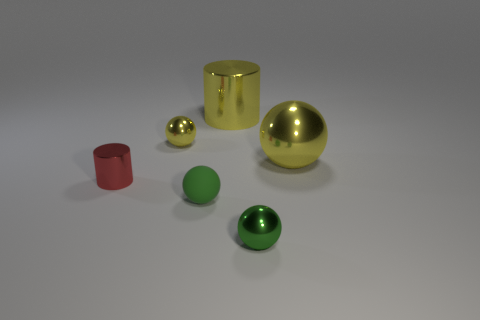There is another sphere that is the same color as the matte ball; what is its material?
Provide a short and direct response. Metal. How many yellow things are there?
Your response must be concise. 3. What number of tiny objects are balls or green metal things?
Make the answer very short. 3. The green shiny object that is the same size as the green rubber sphere is what shape?
Give a very brief answer. Sphere. There is a green sphere that is on the left side of the object behind the small yellow object; what is it made of?
Provide a succinct answer. Rubber. Do the rubber thing and the yellow metallic cylinder have the same size?
Your answer should be compact. No. What number of objects are things that are in front of the matte sphere or big shiny balls?
Keep it short and to the point. 2. There is a tiny green thing that is behind the small green metallic object right of the small rubber object; what shape is it?
Offer a terse response. Sphere. There is a red object; does it have the same size as the metallic ball that is in front of the tiny red cylinder?
Offer a very short reply. Yes. What is the large yellow thing in front of the yellow cylinder made of?
Offer a terse response. Metal. 